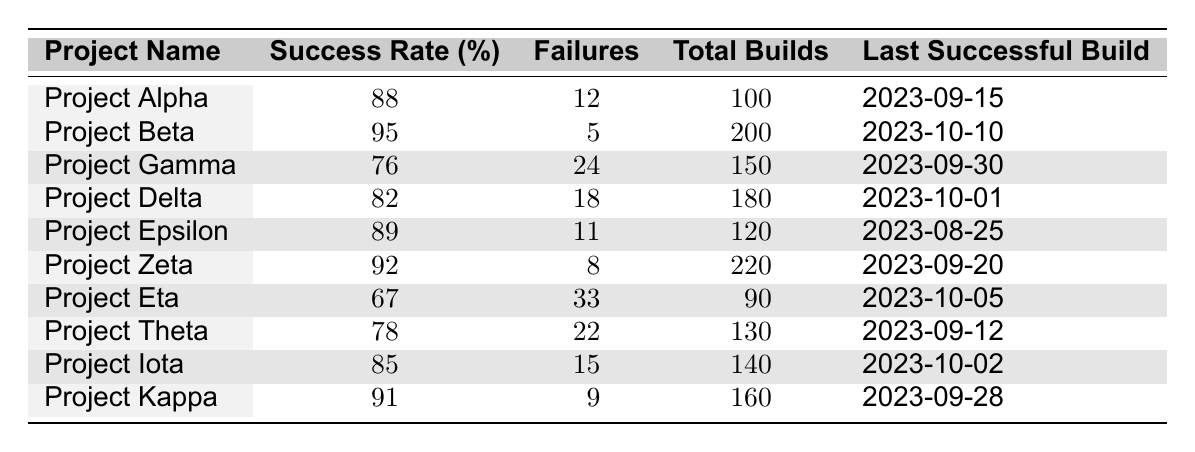What is the success rate of Project Beta? The table shows a specific column for success rates, and by locating Project Beta, we see the success rate listed next to it.
Answer: 95% How many total builds were executed for Project Zeta? In the table, the total builds column shows the number next to Project Zeta.
Answer: 220 Which project had the most failures? To find the project with the most failures, we compare the failures column for all projects, and Project Eta has the highest number of failures listed.
Answer: Project Eta What is the average success rate of all projects? We calculate the average by summing up all the success rates (88 + 95 + 76 + 82 + 89 + 92 + 67 + 78 + 85 + 91 =  911) and then dividing by the total number of projects (10), resulting in 911/10 = 91.1.
Answer: 91.1% Is Project Delta's success rate greater than 80%? By looking at Project Delta in the success rate column, we see it is 82%, which is greater than 80%. Therefore, the answer is yes.
Answer: Yes How many projects have a success rate below 80%? Checking the success rates, we see two projects: Project Gamma (76%) and Project Eta (67%). The count of these projects gives us the answer.
Answer: 2 What is the total number of failures across all projects? We add up the failures: (12 + 5 + 24 + 18 + 11 + 8 + 33 + 22 + 15 + 9 =  237) to find the total number of failures across all projects.
Answer: 237 Which project has the last successful build date that is the most recent? Looking at the last successful build date for each project, Project Beta has the date of 2023-10-10, which is the most recent in the list.
Answer: Project Beta If there were 100 builds for Project Gamma, what would its success and failure numbers be based on its success rate? Project Gamma's success rate is 76%, meaning 76 builds would be successful (calculated as 100 * 76/100), and the failures would be 24 (100 - 76).
Answer: 76 successes, 24 failures How does the success rate of Project Kappa compare to the average success rate of all projects? Project Kappa's success rate is 91%, which we previously calculated the average success rate as 91.1%. By comparison, it is slightly lower than the average.
Answer: Slightly lower than average 